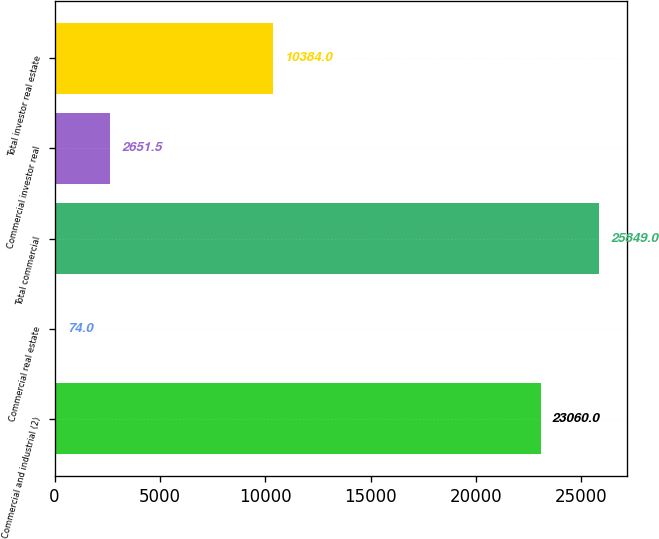Convert chart to OTSL. <chart><loc_0><loc_0><loc_500><loc_500><bar_chart><fcel>Commercial and industrial (2)<fcel>Commercial real estate<fcel>Total commercial<fcel>Commercial investor real<fcel>Total investor real estate<nl><fcel>23060<fcel>74<fcel>25849<fcel>2651.5<fcel>10384<nl></chart> 